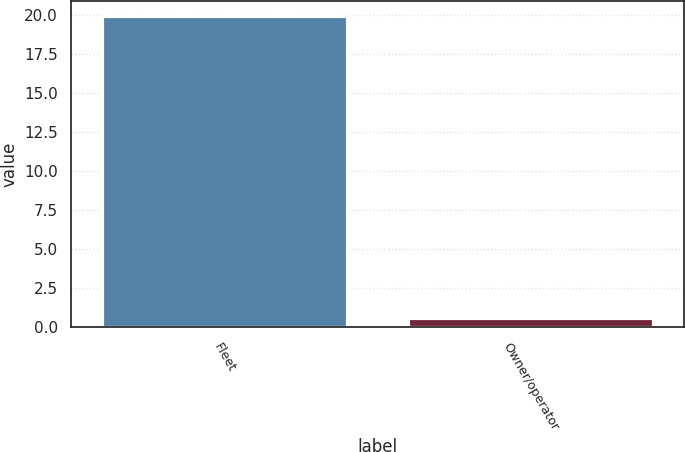Convert chart. <chart><loc_0><loc_0><loc_500><loc_500><bar_chart><fcel>Fleet<fcel>Owner/operator<nl><fcel>19.9<fcel>0.6<nl></chart> 